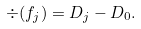Convert formula to latex. <formula><loc_0><loc_0><loc_500><loc_500>\div ( f _ { j } ) = D _ { j } - D _ { 0 } .</formula> 